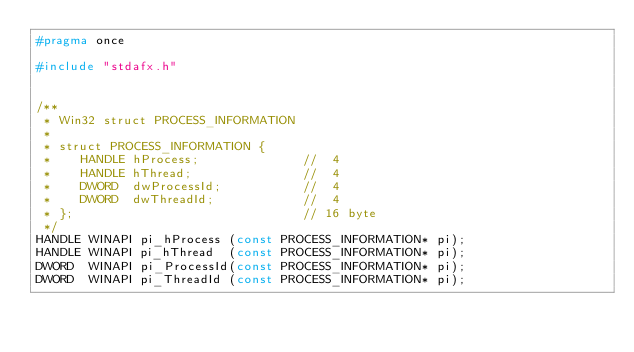Convert code to text. <code><loc_0><loc_0><loc_500><loc_500><_C_>#pragma once

#include "stdafx.h"


/**
 * Win32 struct PROCESS_INFORMATION
 *
 * struct PROCESS_INFORMATION {
 *    HANDLE hProcess;              //  4
 *    HANDLE hThread;               //  4
 *    DWORD  dwProcessId;           //  4
 *    DWORD  dwThreadId;            //  4
 * };                               // 16 byte
 */
HANDLE WINAPI pi_hProcess (const PROCESS_INFORMATION* pi);
HANDLE WINAPI pi_hThread  (const PROCESS_INFORMATION* pi);
DWORD  WINAPI pi_ProcessId(const PROCESS_INFORMATION* pi);
DWORD  WINAPI pi_ThreadId (const PROCESS_INFORMATION* pi);
</code> 